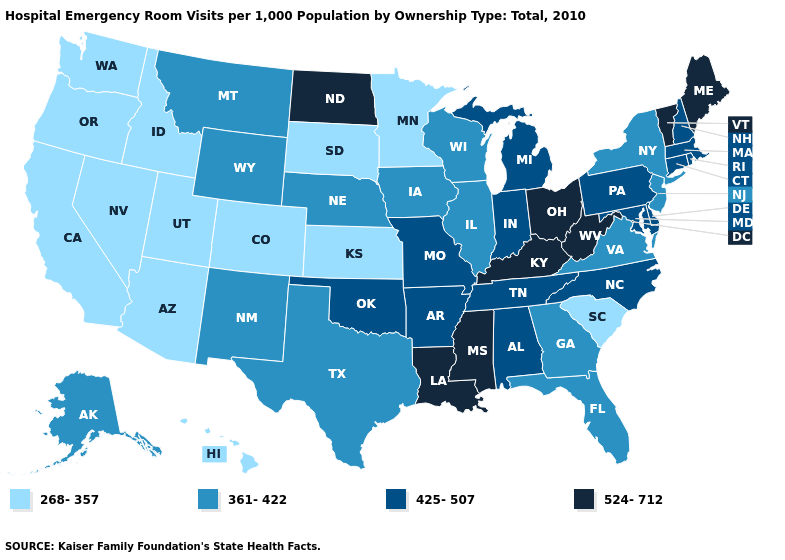What is the value of New York?
Give a very brief answer. 361-422. Name the states that have a value in the range 361-422?
Give a very brief answer. Alaska, Florida, Georgia, Illinois, Iowa, Montana, Nebraska, New Jersey, New Mexico, New York, Texas, Virginia, Wisconsin, Wyoming. What is the value of Virginia?
Give a very brief answer. 361-422. Which states have the highest value in the USA?
Quick response, please. Kentucky, Louisiana, Maine, Mississippi, North Dakota, Ohio, Vermont, West Virginia. Which states hav the highest value in the West?
Answer briefly. Alaska, Montana, New Mexico, Wyoming. Name the states that have a value in the range 524-712?
Quick response, please. Kentucky, Louisiana, Maine, Mississippi, North Dakota, Ohio, Vermont, West Virginia. Does Idaho have the highest value in the West?
Write a very short answer. No. What is the highest value in the South ?
Write a very short answer. 524-712. What is the value of Arkansas?
Write a very short answer. 425-507. Name the states that have a value in the range 361-422?
Short answer required. Alaska, Florida, Georgia, Illinois, Iowa, Montana, Nebraska, New Jersey, New Mexico, New York, Texas, Virginia, Wisconsin, Wyoming. What is the value of Rhode Island?
Concise answer only. 425-507. Among the states that border Kentucky , does Illinois have the lowest value?
Short answer required. Yes. Does Massachusetts have the same value as Nevada?
Be succinct. No. Which states have the lowest value in the South?
Quick response, please. South Carolina. Which states have the highest value in the USA?
Short answer required. Kentucky, Louisiana, Maine, Mississippi, North Dakota, Ohio, Vermont, West Virginia. 